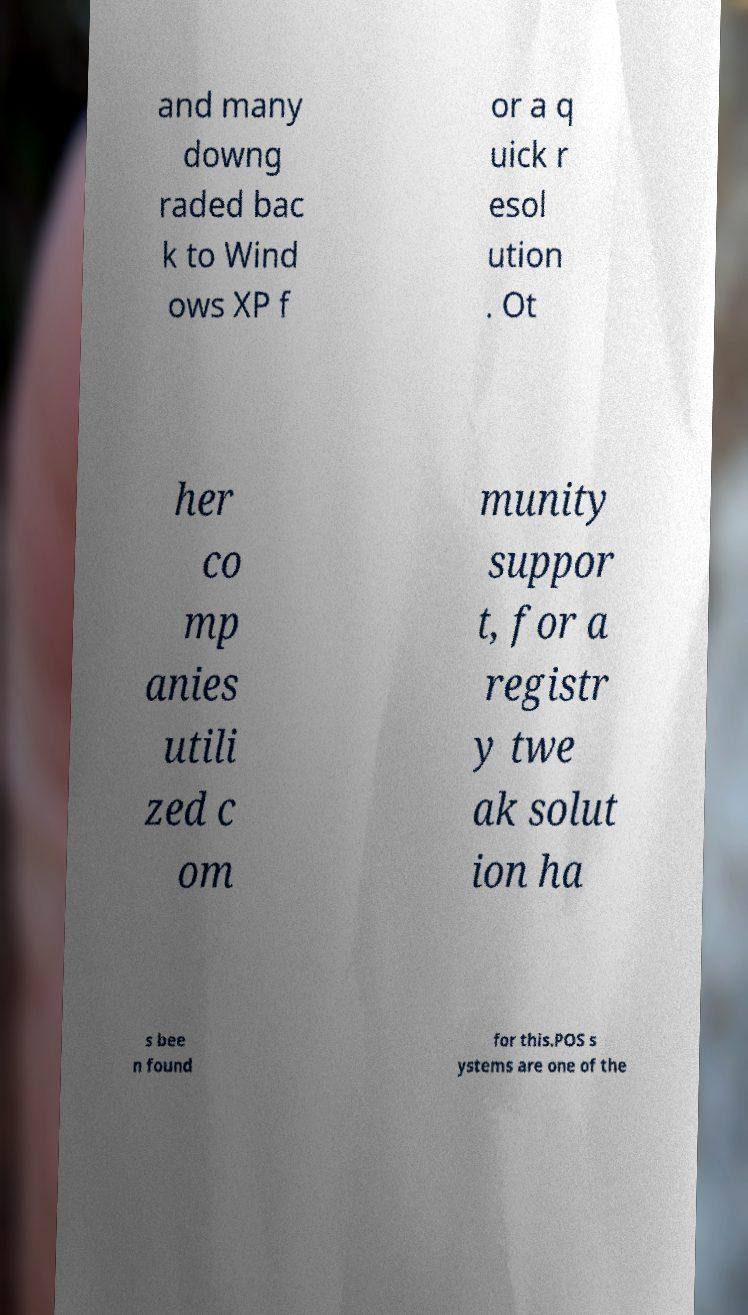Can you read and provide the text displayed in the image?This photo seems to have some interesting text. Can you extract and type it out for me? and many downg raded bac k to Wind ows XP f or a q uick r esol ution . Ot her co mp anies utili zed c om munity suppor t, for a registr y twe ak solut ion ha s bee n found for this.POS s ystems are one of the 